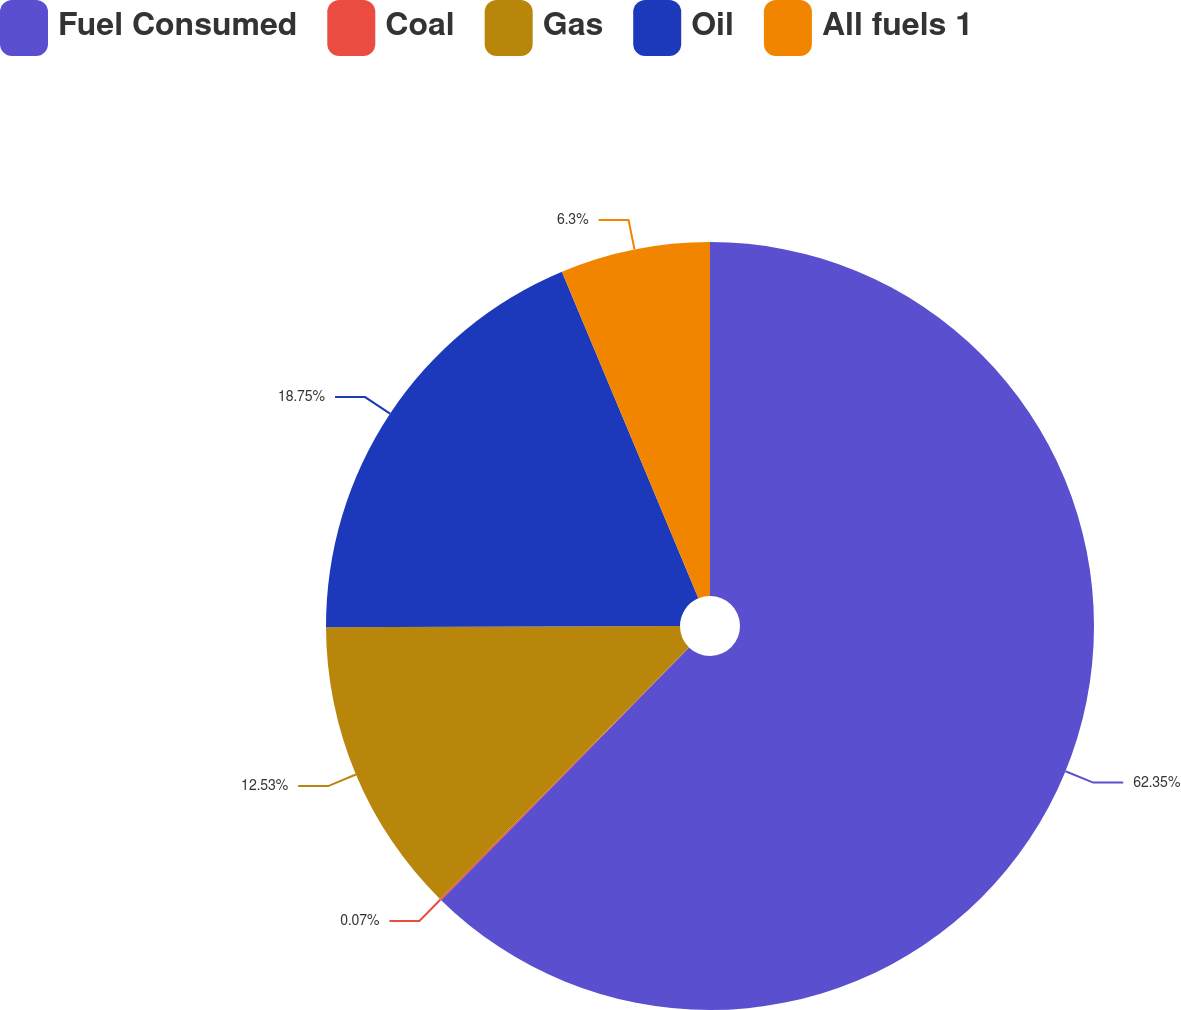<chart> <loc_0><loc_0><loc_500><loc_500><pie_chart><fcel>Fuel Consumed<fcel>Coal<fcel>Gas<fcel>Oil<fcel>All fuels 1<nl><fcel>62.34%<fcel>0.07%<fcel>12.53%<fcel>18.75%<fcel>6.3%<nl></chart> 